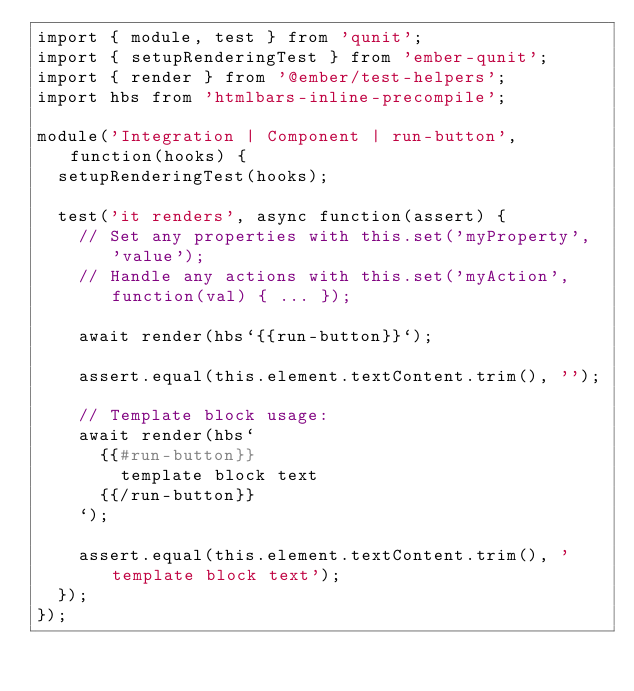<code> <loc_0><loc_0><loc_500><loc_500><_JavaScript_>import { module, test } from 'qunit';
import { setupRenderingTest } from 'ember-qunit';
import { render } from '@ember/test-helpers';
import hbs from 'htmlbars-inline-precompile';

module('Integration | Component | run-button', function(hooks) {
  setupRenderingTest(hooks);

  test('it renders', async function(assert) {
    // Set any properties with this.set('myProperty', 'value');
    // Handle any actions with this.set('myAction', function(val) { ... });

    await render(hbs`{{run-button}}`);

    assert.equal(this.element.textContent.trim(), '');

    // Template block usage:
    await render(hbs`
      {{#run-button}}
        template block text
      {{/run-button}}
    `);

    assert.equal(this.element.textContent.trim(), 'template block text');
  });
});
</code> 